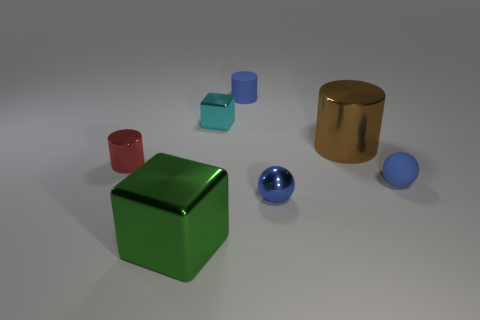Subtract 1 cylinders. How many cylinders are left? 2 Add 1 blue rubber objects. How many objects exist? 8 Subtract all cylinders. How many objects are left? 4 Subtract all big blue rubber balls. Subtract all small matte things. How many objects are left? 5 Add 3 big brown objects. How many big brown objects are left? 4 Add 1 blue cylinders. How many blue cylinders exist? 2 Subtract 0 red cubes. How many objects are left? 7 